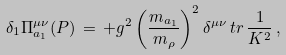Convert formula to latex. <formula><loc_0><loc_0><loc_500><loc_500>\delta _ { 1 } \Pi ^ { \mu \nu } _ { a _ { 1 } } ( P ) \, = \, + g ^ { 2 } \left ( \frac { m _ { a _ { 1 } } } { m _ { \rho } } \right ) ^ { 2 } \delta ^ { \mu \nu } \, t r \, \frac { 1 } { K ^ { 2 } } \, ,</formula> 